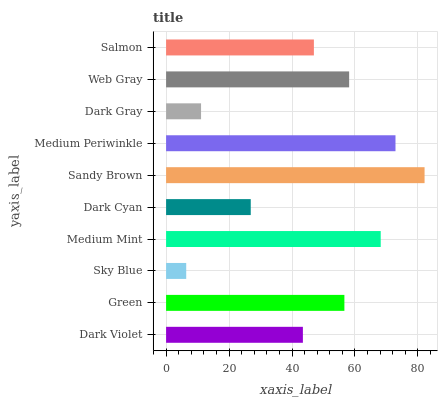Is Sky Blue the minimum?
Answer yes or no. Yes. Is Sandy Brown the maximum?
Answer yes or no. Yes. Is Green the minimum?
Answer yes or no. No. Is Green the maximum?
Answer yes or no. No. Is Green greater than Dark Violet?
Answer yes or no. Yes. Is Dark Violet less than Green?
Answer yes or no. Yes. Is Dark Violet greater than Green?
Answer yes or no. No. Is Green less than Dark Violet?
Answer yes or no. No. Is Green the high median?
Answer yes or no. Yes. Is Salmon the low median?
Answer yes or no. Yes. Is Salmon the high median?
Answer yes or no. No. Is Sky Blue the low median?
Answer yes or no. No. 